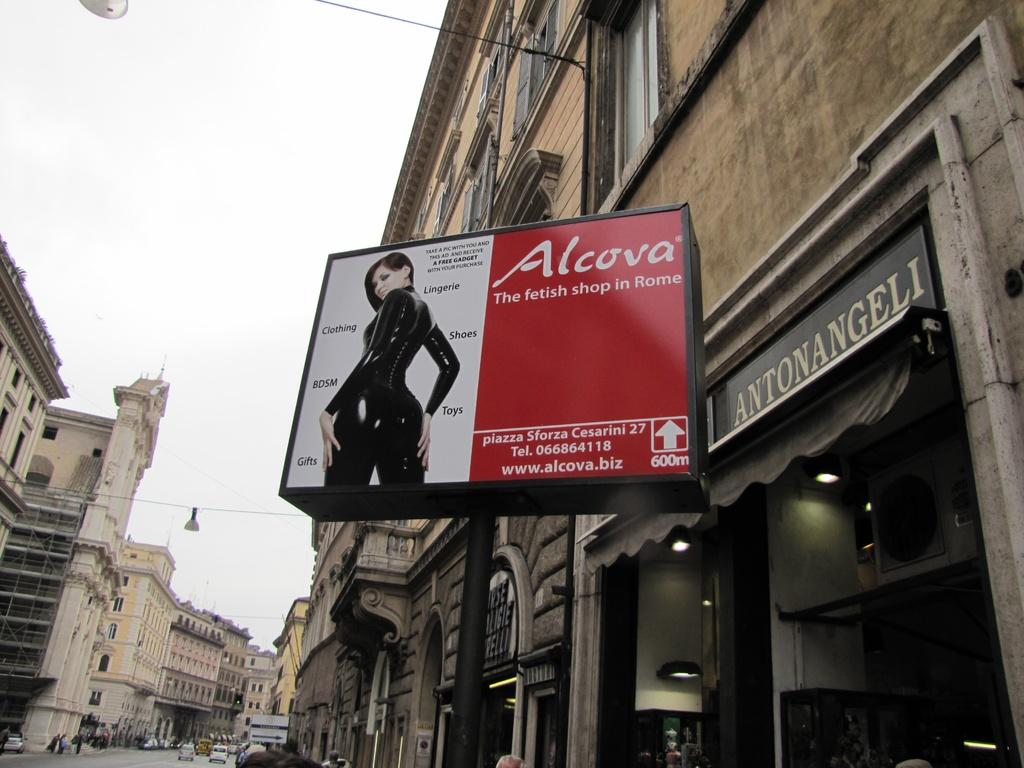Provide a one-sentence caption for the provided image. A sign for Alcova fetish shop with a picture of a woman in leather on it. 